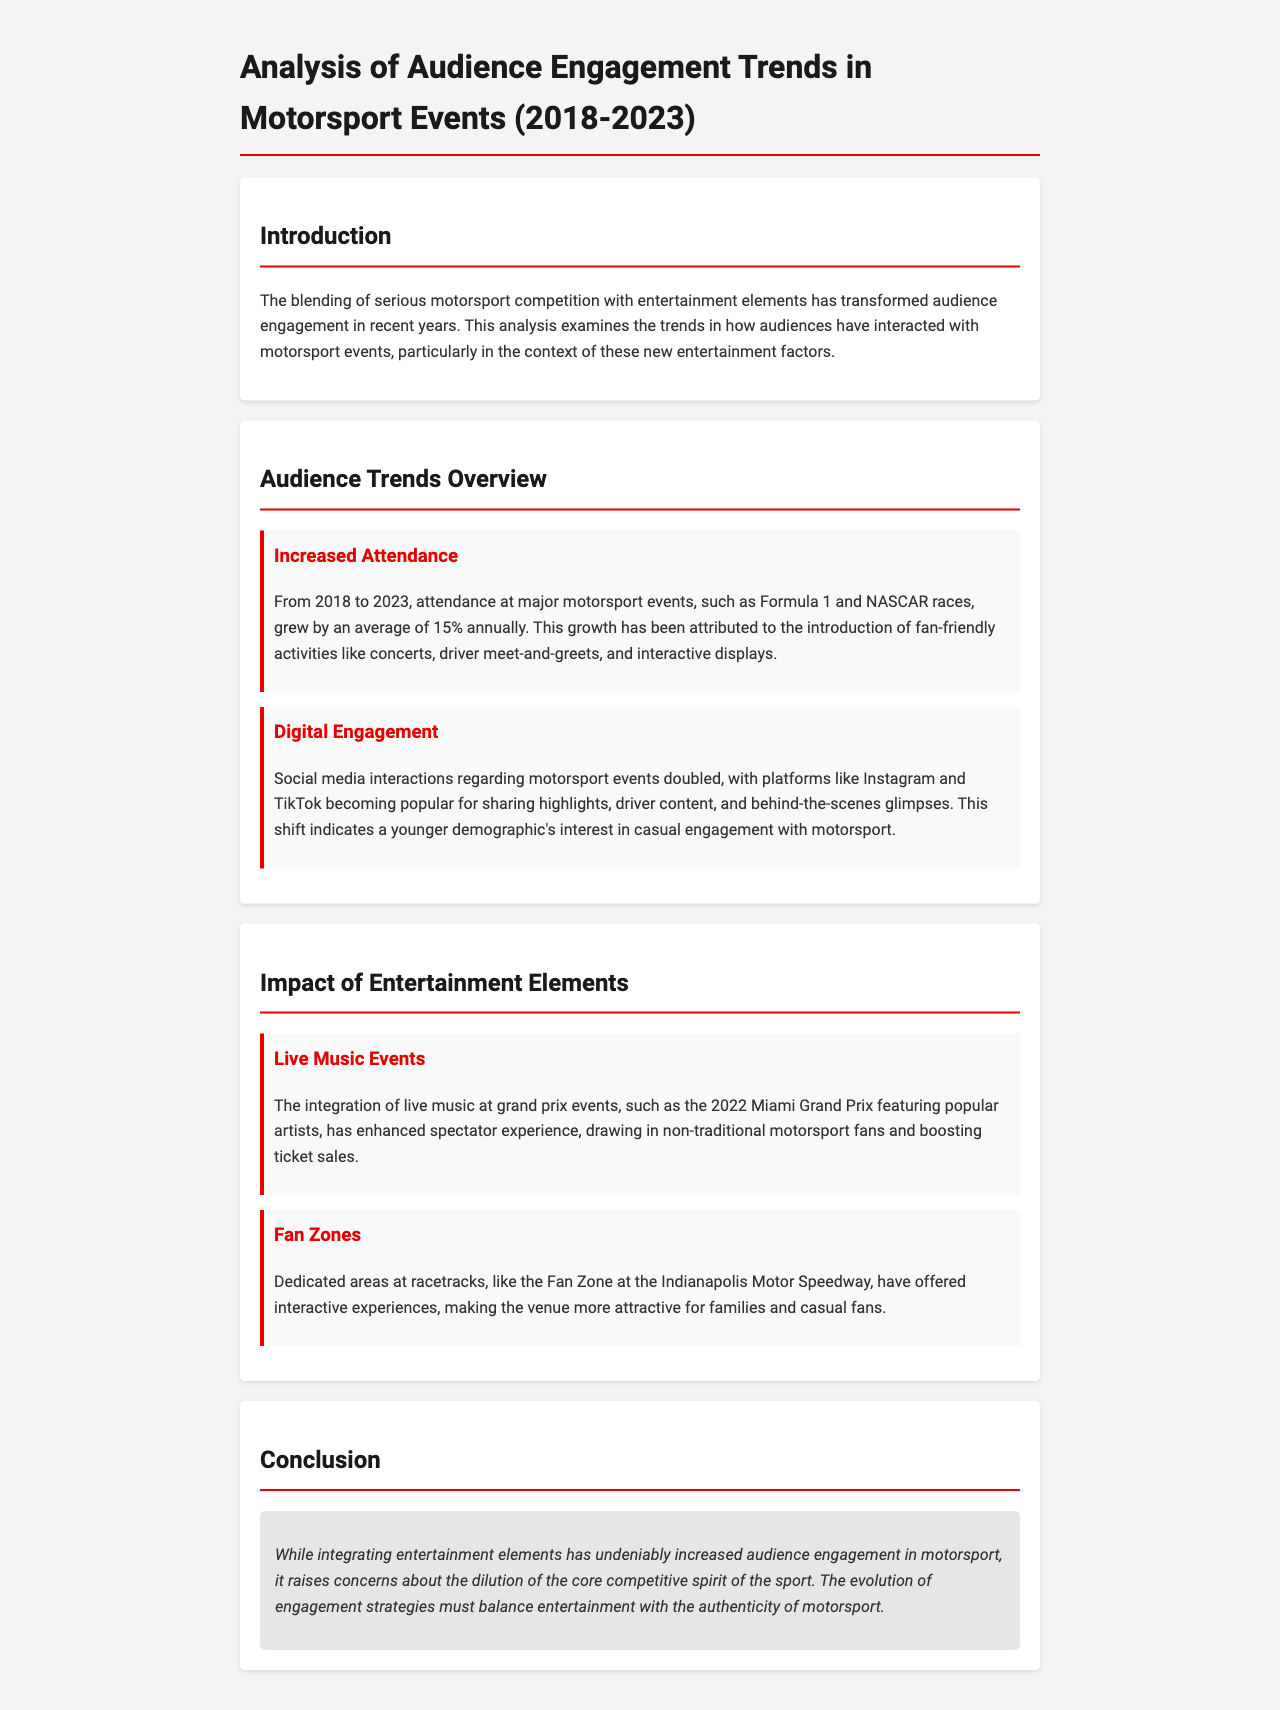What was the average annual attendance growth from 2018 to 2023? The document states that attendance grew by an average of 15% annually from 2018 to 2023.
Answer: 15% Which platforms saw doubled social media interactions? The document mentions that platforms like Instagram and TikTok became popular for this purpose.
Answer: Instagram and TikTok What entertainment element was featured at the 2022 Miami Grand Prix? The integration of live music featuring popular artists is highlighted in the document.
Answer: Live music What has been created at racetracks to attract families? The document refers to dedicated areas known as Fan Zones to make venues more attractive for families.
Answer: Fan Zones What is a concern raised about integrating entertainment elements in motorsport? The document notes concerns about the dilution of the core competitive spirit of the sport.
Answer: Dilution of competitive spirit What percentage growth is attributed to fan-friendly activities? The document attributes attendance growth to the introduction of various fan-friendly activities.
Answer: 15% 